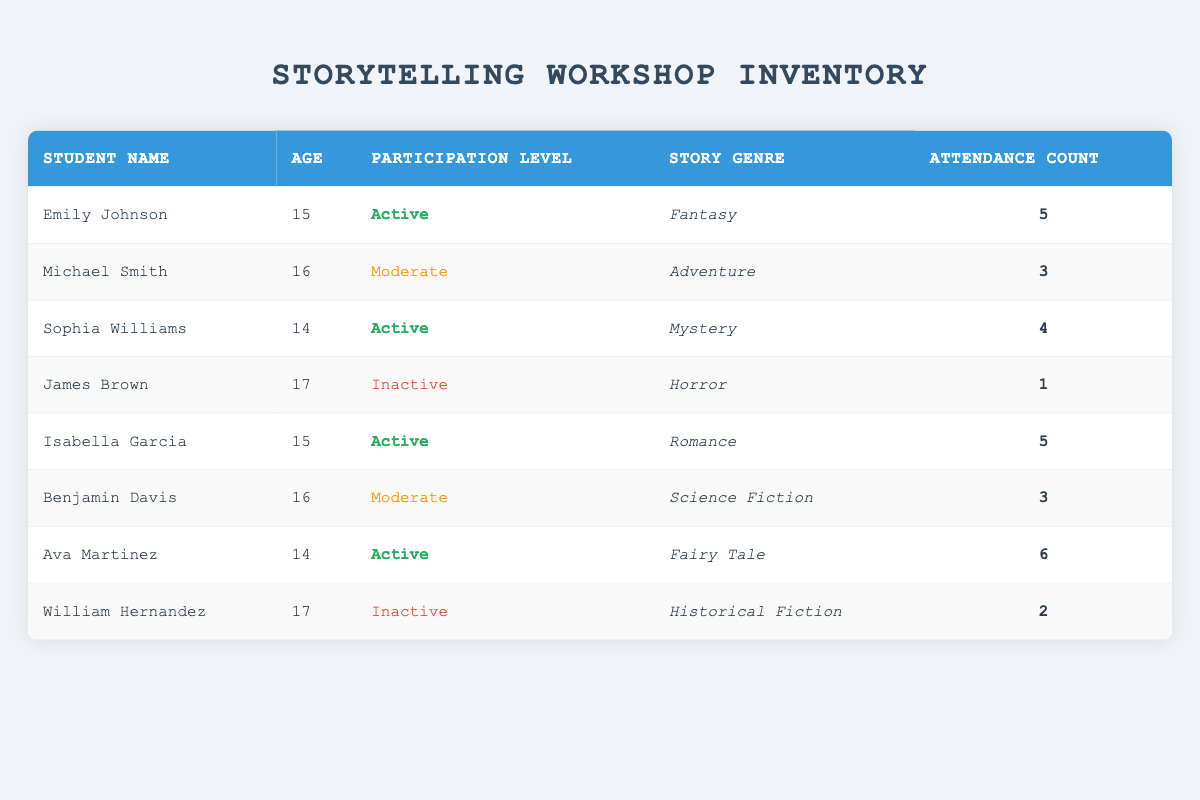What is the most common participation level among students? The table shows three participation levels: Active, Moderate, and Inactive. Counting the occurrences: Active appears 4 times, Moderate appears 2 times, and Inactive appears 2 times. Therefore, Active is the most common participation level.
Answer: Active How many students have attended the storytelling workshop more than 4 times? By examining the Attendance Count column, we see that Ava Martinez (6), Emily Johnson (5), and Isabella Garcia (5) all have attendance counts greater than 4. Thus, there are three students with attendance greater than 4.
Answer: 3 Is there any student who has a participation level of Inactive? The table lists James Brown and William Hernandez as having a participation level of Inactive. Therefore, there are indeed students with this participation level.
Answer: Yes What is the average attendance count for students with an Active participation level? The active participants are Emily Johnson (5), Sophia Williams (4), Isabella Garcia (5), and Ava Martinez (6). We sum their attendance counts: 5 + 4 + 5 + 6 = 20. There are 4 active participants, hence the average is 20/4 = 5.
Answer: 5 Which student has the highest attendance count? Reviewing the Attendance Count column, Ava Martinez holds the highest count with 6.
Answer: Ava Martinez How many students are classified under the Moderate participation level? From the table, we observe Michael Smith and Benjamin Davis both have a participation level of Moderate, giving us a total of 2 students in this category.
Answer: 2 Is there a student aged 17 who is categorized as Active in participation level? Checking the table, we find that both students aged 17, James Brown and William Hernandez, have an Inactive status. Hence, there is no student aged 17 with Active participation.
Answer: No What is the total attendance count from all students in the workshop? By adding every student's attendance counts: 5 + 3 + 4 + 1 + 5 + 3 + 6 + 2 = 29. Therefore, the total attendance count for all students is 29.
Answer: 29 Which genres are represented by students with an Inactive participation level? The inactive students are James Brown, whose genre is Horror, and William Hernandez, whose genre is Historical Fiction. Therefore, the genres represented by inactive students are Horror and Historical Fiction.
Answer: Horror, Historical Fiction 